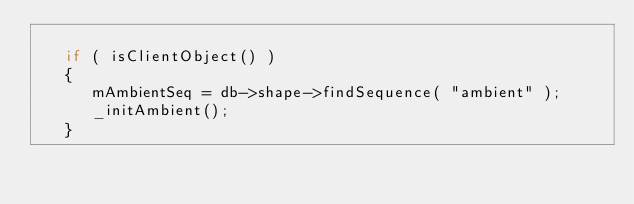<code> <loc_0><loc_0><loc_500><loc_500><_C++_>
   if ( isClientObject() )
   {
      mAmbientSeq = db->shape->findSequence( "ambient" );
      _initAmbient();   
   }
</code> 